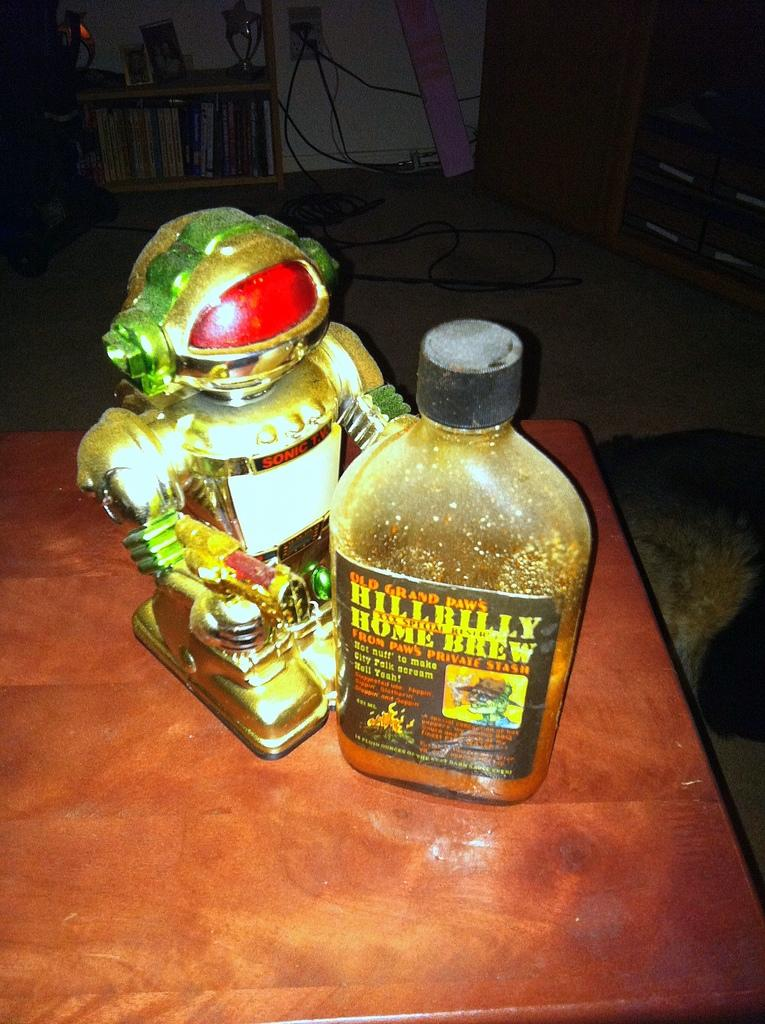Provide a one-sentence caption for the provided image. A robot is standing next to a bottle of Hillbilly home brew. 